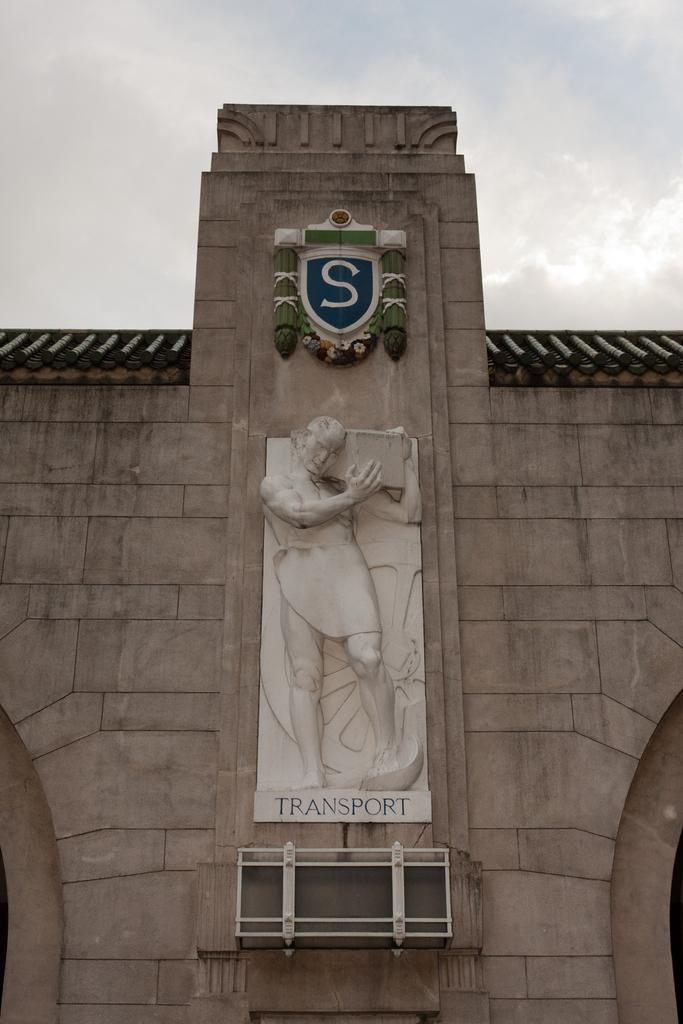<image>
Give a short and clear explanation of the subsequent image. The outside of a building displaying the sculpture of a man carrying something above the word transport. 